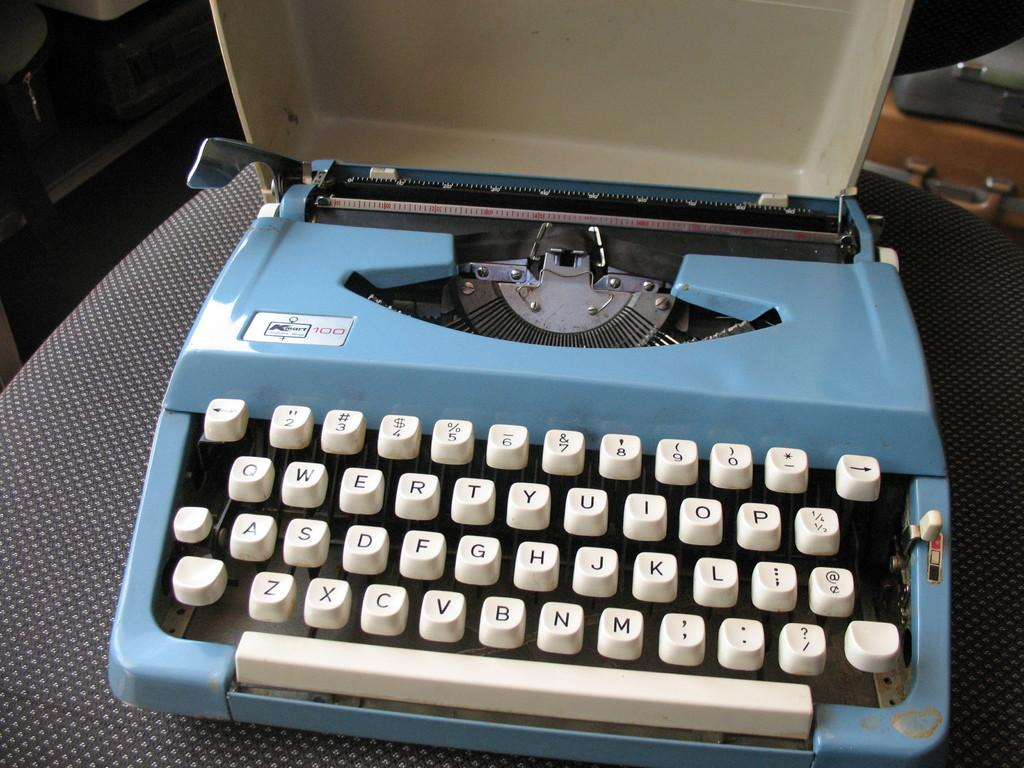What is the main object in the image? There is a type-machine in the image. What is the type-machine resting on? The type-machine is on a black object. Are there any other objects visible in the image? Yes, there are other objects visible in the image. Can you tell me how many toads are sitting on the type-machine in the image? There are no toads present in the image; the type-machine is the main object. What message is the type-machine displaying as a good-bye to the viewer? The type-machine is not displaying any message, as it is an object and not capable of conveying a message. 